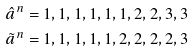<formula> <loc_0><loc_0><loc_500><loc_500>& \hat { a } ^ { n } = 1 , 1 , 1 , 1 , 1 , 1 , 2 , 2 , 3 , 3 \\ & \tilde { a } ^ { n } = 1 , 1 , 1 , 1 , 1 , 2 , 2 , 2 , 2 , 3</formula> 